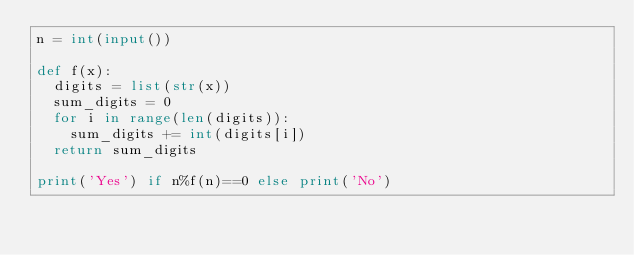<code> <loc_0><loc_0><loc_500><loc_500><_Python_>n = int(input())

def f(x):
  digits = list(str(x))
  sum_digits = 0
  for i in range(len(digits)):
    sum_digits += int(digits[i])
  return sum_digits

print('Yes') if n%f(n)==0 else print('No')
</code> 